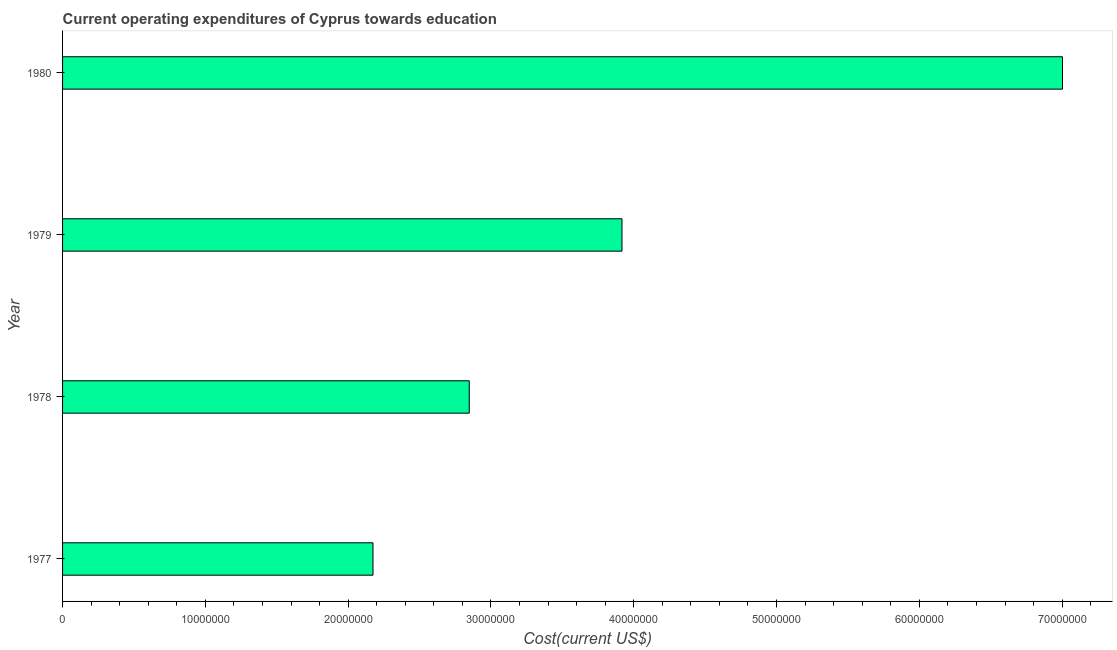Does the graph contain any zero values?
Provide a succinct answer. No. Does the graph contain grids?
Ensure brevity in your answer.  No. What is the title of the graph?
Provide a short and direct response. Current operating expenditures of Cyprus towards education. What is the label or title of the X-axis?
Offer a terse response. Cost(current US$). What is the education expenditure in 1980?
Your answer should be very brief. 7.00e+07. Across all years, what is the maximum education expenditure?
Give a very brief answer. 7.00e+07. Across all years, what is the minimum education expenditure?
Make the answer very short. 2.17e+07. What is the sum of the education expenditure?
Give a very brief answer. 1.59e+08. What is the difference between the education expenditure in 1978 and 1980?
Give a very brief answer. -4.15e+07. What is the average education expenditure per year?
Ensure brevity in your answer.  3.99e+07. What is the median education expenditure?
Give a very brief answer. 3.38e+07. In how many years, is the education expenditure greater than 16000000 US$?
Your answer should be compact. 4. Do a majority of the years between 1980 and 1978 (inclusive) have education expenditure greater than 34000000 US$?
Provide a succinct answer. Yes. What is the ratio of the education expenditure in 1978 to that in 1980?
Your response must be concise. 0.41. Is the education expenditure in 1977 less than that in 1978?
Your response must be concise. Yes. Is the difference between the education expenditure in 1978 and 1979 greater than the difference between any two years?
Provide a succinct answer. No. What is the difference between the highest and the second highest education expenditure?
Make the answer very short. 3.08e+07. Is the sum of the education expenditure in 1978 and 1979 greater than the maximum education expenditure across all years?
Give a very brief answer. No. What is the difference between the highest and the lowest education expenditure?
Ensure brevity in your answer.  4.83e+07. How many bars are there?
Offer a terse response. 4. Are all the bars in the graph horizontal?
Keep it short and to the point. Yes. How many years are there in the graph?
Provide a succinct answer. 4. What is the difference between two consecutive major ticks on the X-axis?
Give a very brief answer. 1.00e+07. Are the values on the major ticks of X-axis written in scientific E-notation?
Your answer should be very brief. No. What is the Cost(current US$) in 1977?
Offer a very short reply. 2.17e+07. What is the Cost(current US$) of 1978?
Your answer should be very brief. 2.85e+07. What is the Cost(current US$) of 1979?
Offer a very short reply. 3.92e+07. What is the Cost(current US$) of 1980?
Offer a terse response. 7.00e+07. What is the difference between the Cost(current US$) in 1977 and 1978?
Give a very brief answer. -6.74e+06. What is the difference between the Cost(current US$) in 1977 and 1979?
Make the answer very short. -1.74e+07. What is the difference between the Cost(current US$) in 1977 and 1980?
Offer a very short reply. -4.83e+07. What is the difference between the Cost(current US$) in 1978 and 1979?
Offer a very short reply. -1.07e+07. What is the difference between the Cost(current US$) in 1978 and 1980?
Offer a very short reply. -4.15e+07. What is the difference between the Cost(current US$) in 1979 and 1980?
Your answer should be compact. -3.08e+07. What is the ratio of the Cost(current US$) in 1977 to that in 1978?
Make the answer very short. 0.76. What is the ratio of the Cost(current US$) in 1977 to that in 1979?
Give a very brief answer. 0.56. What is the ratio of the Cost(current US$) in 1977 to that in 1980?
Provide a short and direct response. 0.31. What is the ratio of the Cost(current US$) in 1978 to that in 1979?
Provide a short and direct response. 0.73. What is the ratio of the Cost(current US$) in 1978 to that in 1980?
Provide a short and direct response. 0.41. What is the ratio of the Cost(current US$) in 1979 to that in 1980?
Keep it short and to the point. 0.56. 